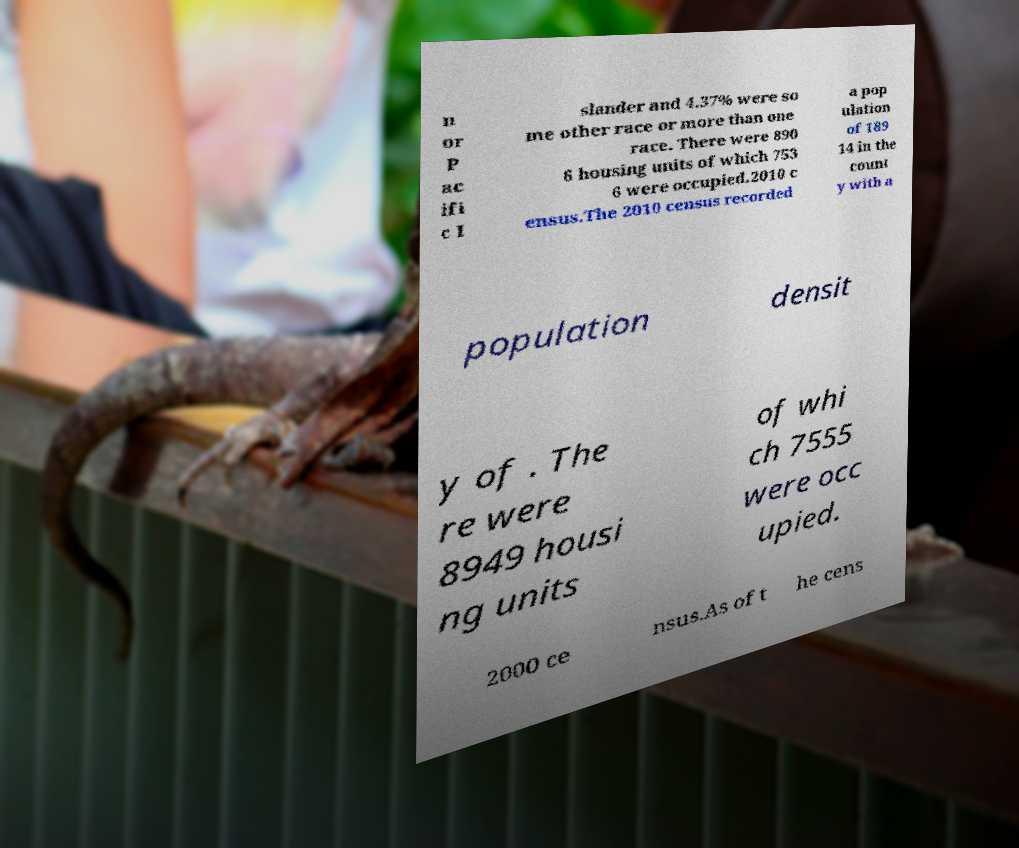What messages or text are displayed in this image? I need them in a readable, typed format. n or P ac ifi c I slander and 4.37% were so me other race or more than one race. There were 890 6 housing units of which 753 6 were occupied.2010 c ensus.The 2010 census recorded a pop ulation of 189 14 in the count y with a population densit y of . The re were 8949 housi ng units of whi ch 7555 were occ upied. 2000 ce nsus.As of t he cens 